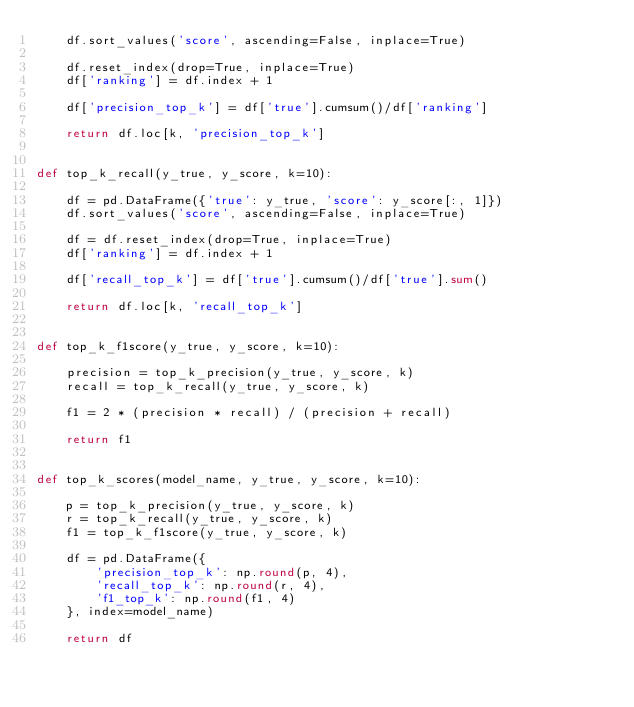Convert code to text. <code><loc_0><loc_0><loc_500><loc_500><_Python_>    df.sort_values('score', ascending=False, inplace=True)
    
    df.reset_index(drop=True, inplace=True)
    df['ranking'] = df.index + 1

    df['precision_top_k'] = df['true'].cumsum()/df['ranking'] 

    return df.loc[k, 'precision_top_k']


def top_k_recall(y_true, y_score, k=10):
    
    df = pd.DataFrame({'true': y_true, 'score': y_score[:, 1]})
    df.sort_values('score', ascending=False, inplace=True)

    df = df.reset_index(drop=True, inplace=True)
    df['ranking'] = df.index + 1 

    df['recall_top_k'] = df['true'].cumsum()/df['true'].sum()

    return df.loc[k, 'recall_top_k']


def top_k_f1score(y_true, y_score, k=10):

    precision = top_k_precision(y_true, y_score, k)
    recall = top_k_recall(y_true, y_score, k)

    f1 = 2 * (precision * recall) / (precision + recall)

    return f1


def top_k_scores(model_name, y_true, y_score, k=10):

    p = top_k_precision(y_true, y_score, k)
    r = top_k_recall(y_true, y_score, k)
    f1 = top_k_f1score(y_true, y_score, k)

    df = pd.DataFrame({
        'precision_top_k': np.round(p, 4),
        'recall_top_k': np.round(r, 4),
        'f1_top_k': np.round(f1, 4)
    }, index=model_name)

    return df</code> 